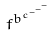<formula> <loc_0><loc_0><loc_500><loc_500>f ^ { b ^ { c ^ { - ^ { - ^ { - } } } } }</formula> 